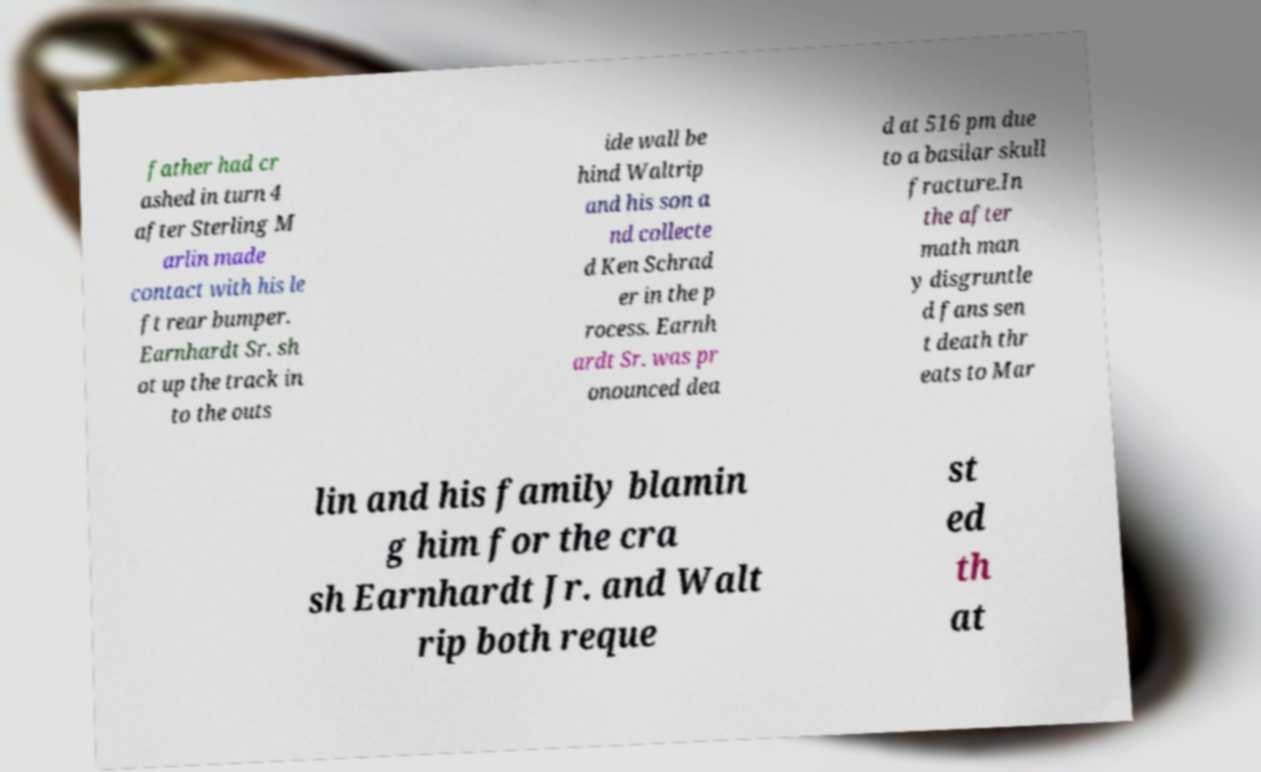Could you assist in decoding the text presented in this image and type it out clearly? father had cr ashed in turn 4 after Sterling M arlin made contact with his le ft rear bumper. Earnhardt Sr. sh ot up the track in to the outs ide wall be hind Waltrip and his son a nd collecte d Ken Schrad er in the p rocess. Earnh ardt Sr. was pr onounced dea d at 516 pm due to a basilar skull fracture.In the after math man y disgruntle d fans sen t death thr eats to Mar lin and his family blamin g him for the cra sh Earnhardt Jr. and Walt rip both reque st ed th at 